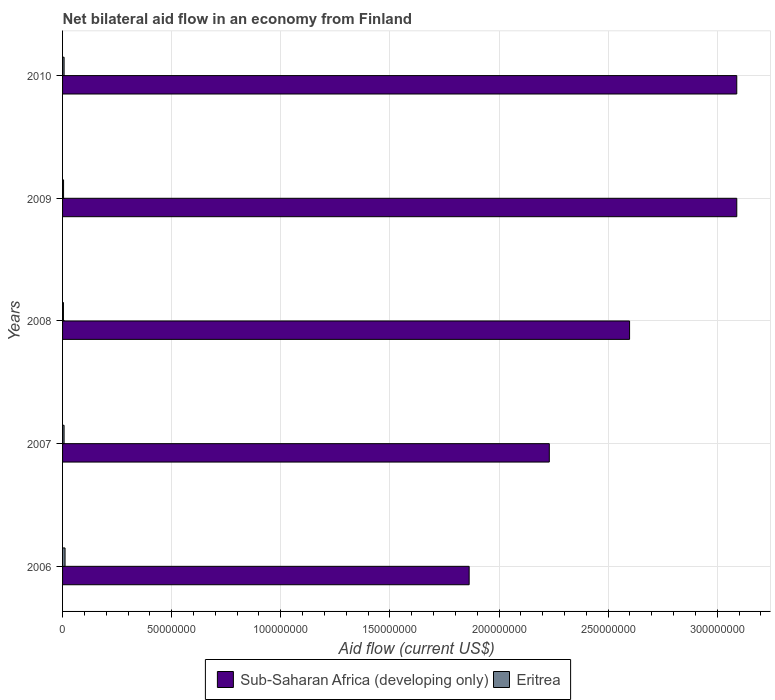How many different coloured bars are there?
Make the answer very short. 2. How many groups of bars are there?
Your answer should be very brief. 5. Are the number of bars per tick equal to the number of legend labels?
Offer a very short reply. Yes. Are the number of bars on each tick of the Y-axis equal?
Ensure brevity in your answer.  Yes. How many bars are there on the 4th tick from the top?
Give a very brief answer. 2. How many bars are there on the 4th tick from the bottom?
Ensure brevity in your answer.  2. What is the label of the 1st group of bars from the top?
Offer a very short reply. 2010. In how many cases, is the number of bars for a given year not equal to the number of legend labels?
Your response must be concise. 0. What is the net bilateral aid flow in Sub-Saharan Africa (developing only) in 2010?
Keep it short and to the point. 3.09e+08. Across all years, what is the maximum net bilateral aid flow in Eritrea?
Provide a succinct answer. 1.14e+06. In which year was the net bilateral aid flow in Eritrea maximum?
Provide a short and direct response. 2006. What is the total net bilateral aid flow in Eritrea in the graph?
Make the answer very short. 3.39e+06. What is the difference between the net bilateral aid flow in Eritrea in 2007 and that in 2008?
Offer a terse response. 2.90e+05. What is the difference between the net bilateral aid flow in Eritrea in 2010 and the net bilateral aid flow in Sub-Saharan Africa (developing only) in 2007?
Your answer should be compact. -2.22e+08. What is the average net bilateral aid flow in Sub-Saharan Africa (developing only) per year?
Keep it short and to the point. 2.57e+08. In the year 2008, what is the difference between the net bilateral aid flow in Sub-Saharan Africa (developing only) and net bilateral aid flow in Eritrea?
Offer a very short reply. 2.59e+08. In how many years, is the net bilateral aid flow in Eritrea greater than 310000000 US$?
Ensure brevity in your answer.  0. What is the ratio of the net bilateral aid flow in Eritrea in 2006 to that in 2009?
Your answer should be very brief. 2.48. What is the difference between the highest and the lowest net bilateral aid flow in Eritrea?
Offer a terse response. 7.40e+05. In how many years, is the net bilateral aid flow in Sub-Saharan Africa (developing only) greater than the average net bilateral aid flow in Sub-Saharan Africa (developing only) taken over all years?
Your answer should be very brief. 3. What does the 1st bar from the top in 2008 represents?
Your answer should be very brief. Eritrea. What does the 2nd bar from the bottom in 2008 represents?
Your response must be concise. Eritrea. How many bars are there?
Give a very brief answer. 10. Are all the bars in the graph horizontal?
Keep it short and to the point. Yes. How many years are there in the graph?
Your answer should be compact. 5. What is the difference between two consecutive major ticks on the X-axis?
Keep it short and to the point. 5.00e+07. Does the graph contain any zero values?
Your answer should be very brief. No. Does the graph contain grids?
Offer a very short reply. Yes. What is the title of the graph?
Give a very brief answer. Net bilateral aid flow in an economy from Finland. What is the label or title of the X-axis?
Provide a short and direct response. Aid flow (current US$). What is the Aid flow (current US$) of Sub-Saharan Africa (developing only) in 2006?
Give a very brief answer. 1.86e+08. What is the Aid flow (current US$) of Eritrea in 2006?
Offer a terse response. 1.14e+06. What is the Aid flow (current US$) in Sub-Saharan Africa (developing only) in 2007?
Provide a short and direct response. 2.23e+08. What is the Aid flow (current US$) in Eritrea in 2007?
Your answer should be compact. 6.90e+05. What is the Aid flow (current US$) of Sub-Saharan Africa (developing only) in 2008?
Provide a succinct answer. 2.60e+08. What is the Aid flow (current US$) in Sub-Saharan Africa (developing only) in 2009?
Keep it short and to the point. 3.09e+08. What is the Aid flow (current US$) of Eritrea in 2009?
Your answer should be compact. 4.60e+05. What is the Aid flow (current US$) in Sub-Saharan Africa (developing only) in 2010?
Make the answer very short. 3.09e+08. Across all years, what is the maximum Aid flow (current US$) in Sub-Saharan Africa (developing only)?
Offer a terse response. 3.09e+08. Across all years, what is the maximum Aid flow (current US$) in Eritrea?
Make the answer very short. 1.14e+06. Across all years, what is the minimum Aid flow (current US$) of Sub-Saharan Africa (developing only)?
Your response must be concise. 1.86e+08. Across all years, what is the minimum Aid flow (current US$) in Eritrea?
Your response must be concise. 4.00e+05. What is the total Aid flow (current US$) of Sub-Saharan Africa (developing only) in the graph?
Ensure brevity in your answer.  1.29e+09. What is the total Aid flow (current US$) of Eritrea in the graph?
Give a very brief answer. 3.39e+06. What is the difference between the Aid flow (current US$) in Sub-Saharan Africa (developing only) in 2006 and that in 2007?
Your answer should be compact. -3.67e+07. What is the difference between the Aid flow (current US$) of Eritrea in 2006 and that in 2007?
Make the answer very short. 4.50e+05. What is the difference between the Aid flow (current US$) in Sub-Saharan Africa (developing only) in 2006 and that in 2008?
Offer a terse response. -7.35e+07. What is the difference between the Aid flow (current US$) in Eritrea in 2006 and that in 2008?
Your response must be concise. 7.40e+05. What is the difference between the Aid flow (current US$) in Sub-Saharan Africa (developing only) in 2006 and that in 2009?
Keep it short and to the point. -1.23e+08. What is the difference between the Aid flow (current US$) in Eritrea in 2006 and that in 2009?
Provide a succinct answer. 6.80e+05. What is the difference between the Aid flow (current US$) of Sub-Saharan Africa (developing only) in 2006 and that in 2010?
Your answer should be very brief. -1.23e+08. What is the difference between the Aid flow (current US$) in Sub-Saharan Africa (developing only) in 2007 and that in 2008?
Keep it short and to the point. -3.68e+07. What is the difference between the Aid flow (current US$) of Sub-Saharan Africa (developing only) in 2007 and that in 2009?
Your answer should be compact. -8.59e+07. What is the difference between the Aid flow (current US$) in Eritrea in 2007 and that in 2009?
Ensure brevity in your answer.  2.30e+05. What is the difference between the Aid flow (current US$) of Sub-Saharan Africa (developing only) in 2007 and that in 2010?
Your answer should be compact. -8.59e+07. What is the difference between the Aid flow (current US$) in Sub-Saharan Africa (developing only) in 2008 and that in 2009?
Give a very brief answer. -4.91e+07. What is the difference between the Aid flow (current US$) in Sub-Saharan Africa (developing only) in 2008 and that in 2010?
Offer a terse response. -4.91e+07. What is the difference between the Aid flow (current US$) of Eritrea in 2008 and that in 2010?
Offer a very short reply. -3.00e+05. What is the difference between the Aid flow (current US$) in Sub-Saharan Africa (developing only) in 2009 and that in 2010?
Give a very brief answer. 10000. What is the difference between the Aid flow (current US$) in Sub-Saharan Africa (developing only) in 2006 and the Aid flow (current US$) in Eritrea in 2007?
Offer a very short reply. 1.86e+08. What is the difference between the Aid flow (current US$) of Sub-Saharan Africa (developing only) in 2006 and the Aid flow (current US$) of Eritrea in 2008?
Your response must be concise. 1.86e+08. What is the difference between the Aid flow (current US$) in Sub-Saharan Africa (developing only) in 2006 and the Aid flow (current US$) in Eritrea in 2009?
Offer a terse response. 1.86e+08. What is the difference between the Aid flow (current US$) of Sub-Saharan Africa (developing only) in 2006 and the Aid flow (current US$) of Eritrea in 2010?
Offer a terse response. 1.86e+08. What is the difference between the Aid flow (current US$) of Sub-Saharan Africa (developing only) in 2007 and the Aid flow (current US$) of Eritrea in 2008?
Provide a short and direct response. 2.23e+08. What is the difference between the Aid flow (current US$) of Sub-Saharan Africa (developing only) in 2007 and the Aid flow (current US$) of Eritrea in 2009?
Keep it short and to the point. 2.23e+08. What is the difference between the Aid flow (current US$) in Sub-Saharan Africa (developing only) in 2007 and the Aid flow (current US$) in Eritrea in 2010?
Ensure brevity in your answer.  2.22e+08. What is the difference between the Aid flow (current US$) in Sub-Saharan Africa (developing only) in 2008 and the Aid flow (current US$) in Eritrea in 2009?
Offer a terse response. 2.59e+08. What is the difference between the Aid flow (current US$) in Sub-Saharan Africa (developing only) in 2008 and the Aid flow (current US$) in Eritrea in 2010?
Provide a succinct answer. 2.59e+08. What is the difference between the Aid flow (current US$) of Sub-Saharan Africa (developing only) in 2009 and the Aid flow (current US$) of Eritrea in 2010?
Keep it short and to the point. 3.08e+08. What is the average Aid flow (current US$) in Sub-Saharan Africa (developing only) per year?
Your response must be concise. 2.57e+08. What is the average Aid flow (current US$) of Eritrea per year?
Offer a terse response. 6.78e+05. In the year 2006, what is the difference between the Aid flow (current US$) of Sub-Saharan Africa (developing only) and Aid flow (current US$) of Eritrea?
Your response must be concise. 1.85e+08. In the year 2007, what is the difference between the Aid flow (current US$) of Sub-Saharan Africa (developing only) and Aid flow (current US$) of Eritrea?
Make the answer very short. 2.22e+08. In the year 2008, what is the difference between the Aid flow (current US$) of Sub-Saharan Africa (developing only) and Aid flow (current US$) of Eritrea?
Give a very brief answer. 2.59e+08. In the year 2009, what is the difference between the Aid flow (current US$) of Sub-Saharan Africa (developing only) and Aid flow (current US$) of Eritrea?
Ensure brevity in your answer.  3.09e+08. In the year 2010, what is the difference between the Aid flow (current US$) in Sub-Saharan Africa (developing only) and Aid flow (current US$) in Eritrea?
Provide a succinct answer. 3.08e+08. What is the ratio of the Aid flow (current US$) in Sub-Saharan Africa (developing only) in 2006 to that in 2007?
Ensure brevity in your answer.  0.84. What is the ratio of the Aid flow (current US$) in Eritrea in 2006 to that in 2007?
Give a very brief answer. 1.65. What is the ratio of the Aid flow (current US$) in Sub-Saharan Africa (developing only) in 2006 to that in 2008?
Provide a short and direct response. 0.72. What is the ratio of the Aid flow (current US$) of Eritrea in 2006 to that in 2008?
Keep it short and to the point. 2.85. What is the ratio of the Aid flow (current US$) in Sub-Saharan Africa (developing only) in 2006 to that in 2009?
Ensure brevity in your answer.  0.6. What is the ratio of the Aid flow (current US$) of Eritrea in 2006 to that in 2009?
Provide a succinct answer. 2.48. What is the ratio of the Aid flow (current US$) of Sub-Saharan Africa (developing only) in 2006 to that in 2010?
Provide a short and direct response. 0.6. What is the ratio of the Aid flow (current US$) in Eritrea in 2006 to that in 2010?
Your response must be concise. 1.63. What is the ratio of the Aid flow (current US$) in Sub-Saharan Africa (developing only) in 2007 to that in 2008?
Your response must be concise. 0.86. What is the ratio of the Aid flow (current US$) in Eritrea in 2007 to that in 2008?
Keep it short and to the point. 1.73. What is the ratio of the Aid flow (current US$) in Sub-Saharan Africa (developing only) in 2007 to that in 2009?
Offer a terse response. 0.72. What is the ratio of the Aid flow (current US$) in Sub-Saharan Africa (developing only) in 2007 to that in 2010?
Make the answer very short. 0.72. What is the ratio of the Aid flow (current US$) of Eritrea in 2007 to that in 2010?
Provide a succinct answer. 0.99. What is the ratio of the Aid flow (current US$) of Sub-Saharan Africa (developing only) in 2008 to that in 2009?
Keep it short and to the point. 0.84. What is the ratio of the Aid flow (current US$) in Eritrea in 2008 to that in 2009?
Your answer should be compact. 0.87. What is the ratio of the Aid flow (current US$) of Sub-Saharan Africa (developing only) in 2008 to that in 2010?
Provide a succinct answer. 0.84. What is the ratio of the Aid flow (current US$) of Sub-Saharan Africa (developing only) in 2009 to that in 2010?
Your answer should be very brief. 1. What is the ratio of the Aid flow (current US$) in Eritrea in 2009 to that in 2010?
Your answer should be very brief. 0.66. What is the difference between the highest and the lowest Aid flow (current US$) in Sub-Saharan Africa (developing only)?
Your answer should be very brief. 1.23e+08. What is the difference between the highest and the lowest Aid flow (current US$) in Eritrea?
Offer a terse response. 7.40e+05. 